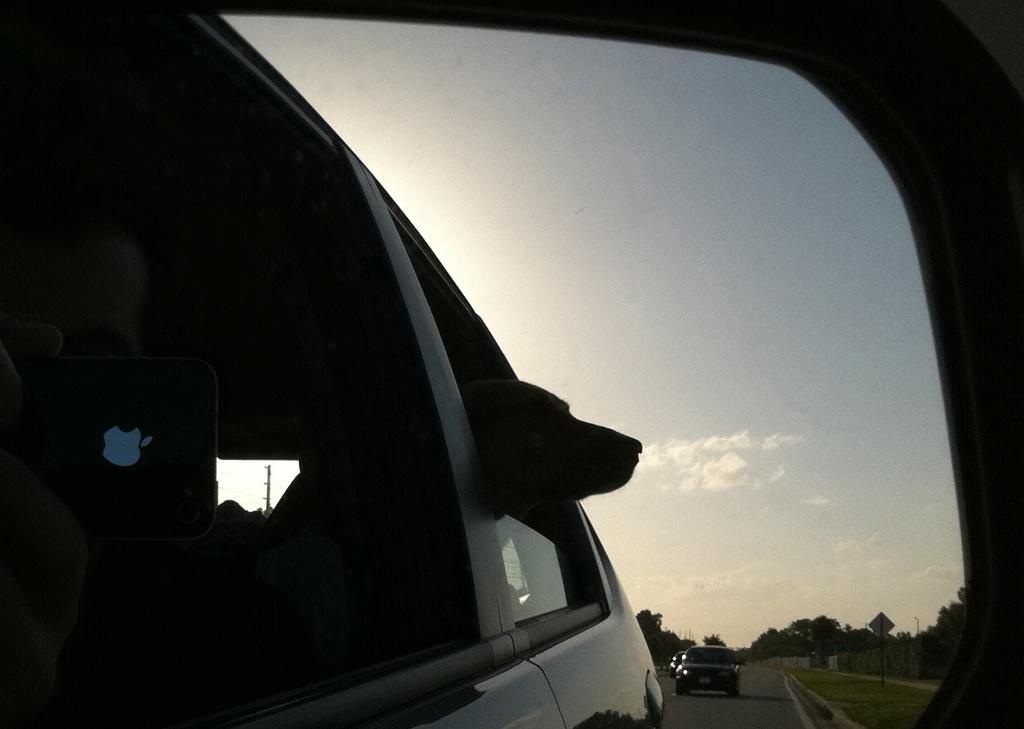How would you summarize this image in a sentence or two? This picture consist of reflection. On the left we can see dog in the car and we can see a person holding a mobile phone and sitting in the car. In the background we can see the sky, trees, green grass, vehicles running on the road and some other items. 